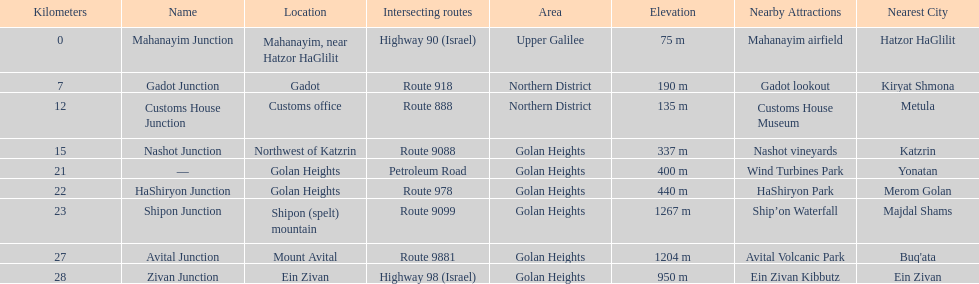What is the number of routes that intersect highway 91? 9. 